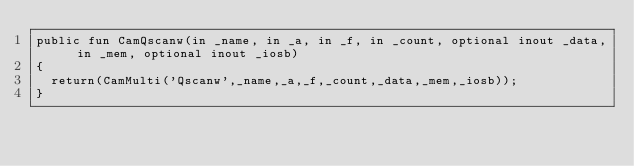Convert code to text. <code><loc_0><loc_0><loc_500><loc_500><_SML_>public fun CamQscanw(in _name, in _a, in _f, in _count, optional inout _data, in _mem, optional inout _iosb)
{
  return(CamMulti('Qscanw',_name,_a,_f,_count,_data,_mem,_iosb));
}
</code> 